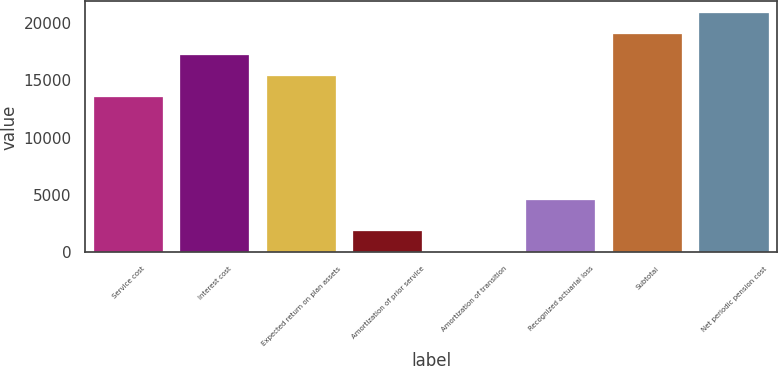<chart> <loc_0><loc_0><loc_500><loc_500><bar_chart><fcel>Service cost<fcel>Interest cost<fcel>Expected return on plan assets<fcel>Amortization of prior service<fcel>Amortization of transition<fcel>Recognized actuarial loss<fcel>Subtotal<fcel>Net periodic pension cost<nl><fcel>13532<fcel>17186.4<fcel>15359.2<fcel>1846.2<fcel>19<fcel>4544<fcel>19013.6<fcel>20840.8<nl></chart> 